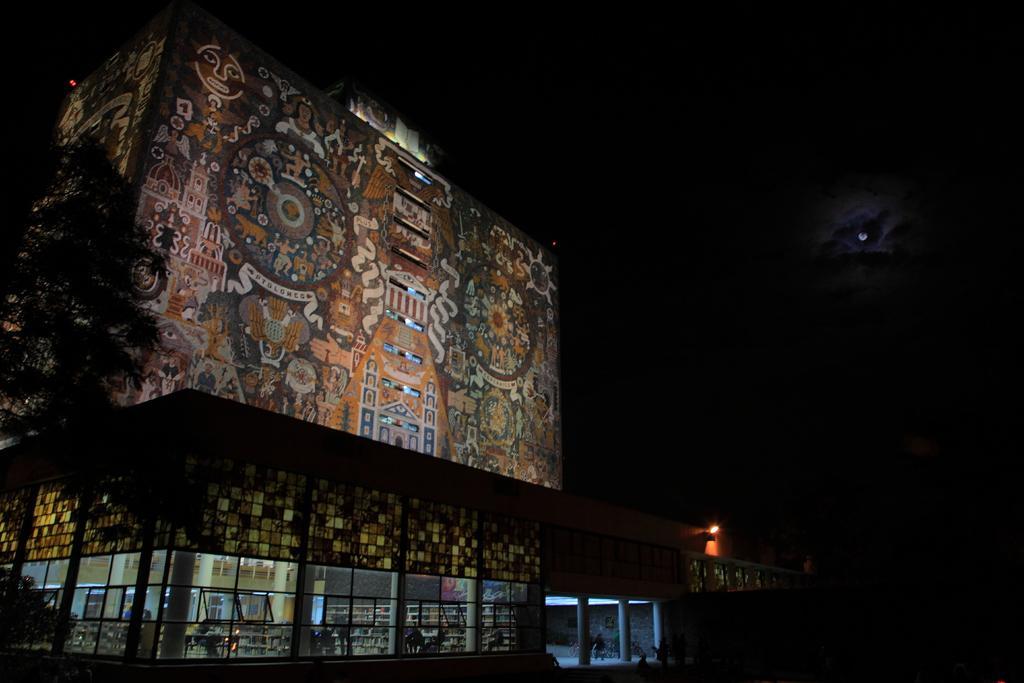Can you describe this image briefly? In this image in the center there is one building and at the bottom there are some glass windows, pillars and some persons are walking. And on the left side there is a tree, on the top of the image there is sky. 